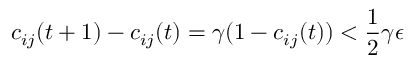Convert formula to latex. <formula><loc_0><loc_0><loc_500><loc_500>c _ { i j } ( t + 1 ) - c _ { i j } ( t ) = \gamma ( 1 - c _ { i j } ( t ) ) < \frac { 1 } { 2 } \gamma \epsilon</formula> 